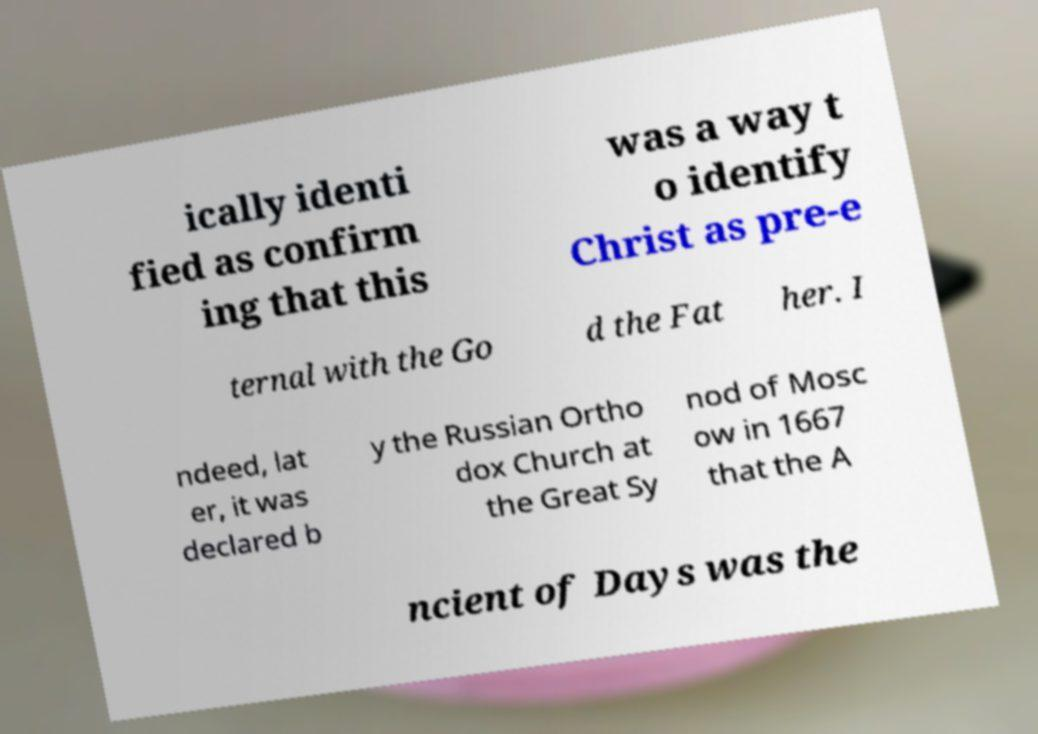Please read and relay the text visible in this image. What does it say? ically identi fied as confirm ing that this was a way t o identify Christ as pre-e ternal with the Go d the Fat her. I ndeed, lat er, it was declared b y the Russian Ortho dox Church at the Great Sy nod of Mosc ow in 1667 that the A ncient of Days was the 